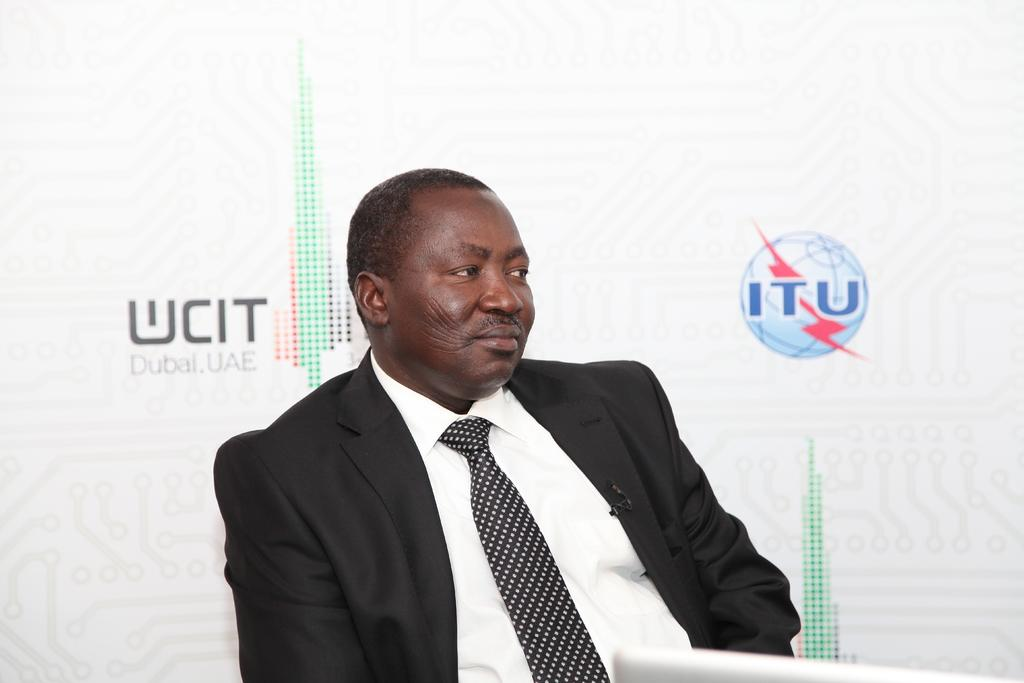What is the person in the image wearing on their upper body? The person is wearing a white shirt and a black coat. What type of accessory is the person wearing around their neck? The person is wearing a tie. What is the person doing in the image? The person is sitting on a chair. What can be seen in the background of the image? There is a poster in the background. How many symbols are on the poster? The poster has two symbols on it. What type of moon can be seen in the image? There is no moon present in the image. How many legs does the person have in the image? The person has two legs, but this question is absurd because it is not possible for a person to have a different number of legs. 